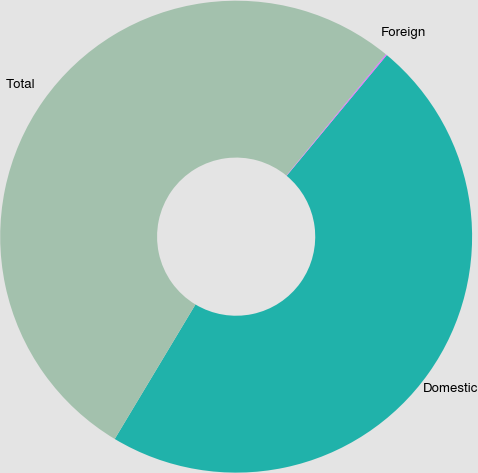<chart> <loc_0><loc_0><loc_500><loc_500><pie_chart><fcel>Domestic<fcel>Foreign<fcel>Total<nl><fcel>47.58%<fcel>0.09%<fcel>52.33%<nl></chart> 